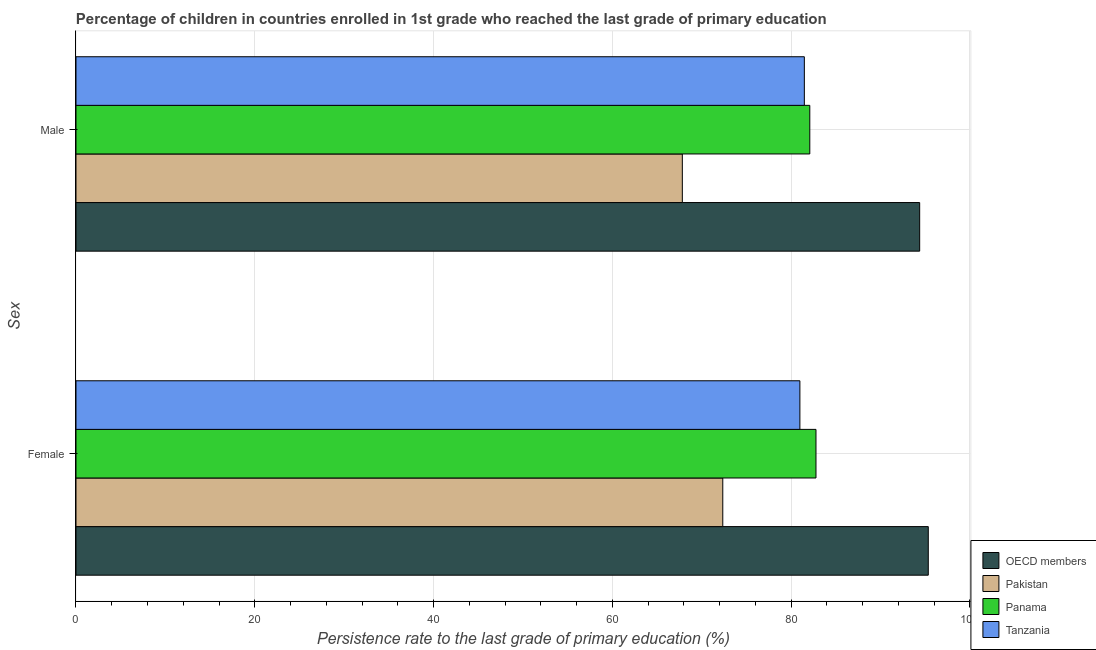How many different coloured bars are there?
Provide a short and direct response. 4. Are the number of bars per tick equal to the number of legend labels?
Ensure brevity in your answer.  Yes. How many bars are there on the 2nd tick from the bottom?
Your answer should be very brief. 4. What is the persistence rate of female students in OECD members?
Offer a very short reply. 95.36. Across all countries, what is the maximum persistence rate of male students?
Offer a terse response. 94.39. Across all countries, what is the minimum persistence rate of male students?
Your answer should be very brief. 67.84. In which country was the persistence rate of male students minimum?
Provide a succinct answer. Pakistan. What is the total persistence rate of male students in the graph?
Give a very brief answer. 325.82. What is the difference between the persistence rate of female students in Tanzania and that in Pakistan?
Your answer should be very brief. 8.63. What is the difference between the persistence rate of female students in OECD members and the persistence rate of male students in Panama?
Your answer should be very brief. 13.26. What is the average persistence rate of male students per country?
Make the answer very short. 81.46. What is the difference between the persistence rate of female students and persistence rate of male students in OECD members?
Your response must be concise. 0.96. In how many countries, is the persistence rate of female students greater than 28 %?
Give a very brief answer. 4. What is the ratio of the persistence rate of male students in Tanzania to that in OECD members?
Offer a terse response. 0.86. Is the persistence rate of female students in Pakistan less than that in Panama?
Make the answer very short. Yes. What does the 2nd bar from the top in Female represents?
Provide a succinct answer. Panama. What is the difference between two consecutive major ticks on the X-axis?
Your response must be concise. 20. Does the graph contain grids?
Offer a terse response. Yes. Where does the legend appear in the graph?
Your answer should be very brief. Bottom right. What is the title of the graph?
Your answer should be compact. Percentage of children in countries enrolled in 1st grade who reached the last grade of primary education. Does "Cuba" appear as one of the legend labels in the graph?
Offer a very short reply. No. What is the label or title of the X-axis?
Your answer should be very brief. Persistence rate to the last grade of primary education (%). What is the label or title of the Y-axis?
Your answer should be compact. Sex. What is the Persistence rate to the last grade of primary education (%) in OECD members in Female?
Offer a very short reply. 95.36. What is the Persistence rate to the last grade of primary education (%) in Pakistan in Female?
Provide a succinct answer. 72.36. What is the Persistence rate to the last grade of primary education (%) of Panama in Female?
Keep it short and to the point. 82.79. What is the Persistence rate to the last grade of primary education (%) of Tanzania in Female?
Offer a very short reply. 80.99. What is the Persistence rate to the last grade of primary education (%) of OECD members in Male?
Your answer should be compact. 94.39. What is the Persistence rate to the last grade of primary education (%) in Pakistan in Male?
Provide a succinct answer. 67.84. What is the Persistence rate to the last grade of primary education (%) in Panama in Male?
Offer a terse response. 82.1. What is the Persistence rate to the last grade of primary education (%) of Tanzania in Male?
Ensure brevity in your answer.  81.49. Across all Sex, what is the maximum Persistence rate to the last grade of primary education (%) of OECD members?
Your answer should be compact. 95.36. Across all Sex, what is the maximum Persistence rate to the last grade of primary education (%) of Pakistan?
Your answer should be very brief. 72.36. Across all Sex, what is the maximum Persistence rate to the last grade of primary education (%) of Panama?
Give a very brief answer. 82.79. Across all Sex, what is the maximum Persistence rate to the last grade of primary education (%) in Tanzania?
Make the answer very short. 81.49. Across all Sex, what is the minimum Persistence rate to the last grade of primary education (%) in OECD members?
Your answer should be very brief. 94.39. Across all Sex, what is the minimum Persistence rate to the last grade of primary education (%) in Pakistan?
Keep it short and to the point. 67.84. Across all Sex, what is the minimum Persistence rate to the last grade of primary education (%) in Panama?
Offer a very short reply. 82.1. Across all Sex, what is the minimum Persistence rate to the last grade of primary education (%) of Tanzania?
Offer a very short reply. 80.99. What is the total Persistence rate to the last grade of primary education (%) in OECD members in the graph?
Keep it short and to the point. 189.75. What is the total Persistence rate to the last grade of primary education (%) in Pakistan in the graph?
Provide a short and direct response. 140.2. What is the total Persistence rate to the last grade of primary education (%) in Panama in the graph?
Provide a succinct answer. 164.89. What is the total Persistence rate to the last grade of primary education (%) in Tanzania in the graph?
Keep it short and to the point. 162.48. What is the difference between the Persistence rate to the last grade of primary education (%) in OECD members in Female and that in Male?
Provide a short and direct response. 0.96. What is the difference between the Persistence rate to the last grade of primary education (%) of Pakistan in Female and that in Male?
Your response must be concise. 4.52. What is the difference between the Persistence rate to the last grade of primary education (%) in Panama in Female and that in Male?
Offer a very short reply. 0.69. What is the difference between the Persistence rate to the last grade of primary education (%) in Tanzania in Female and that in Male?
Ensure brevity in your answer.  -0.5. What is the difference between the Persistence rate to the last grade of primary education (%) in OECD members in Female and the Persistence rate to the last grade of primary education (%) in Pakistan in Male?
Keep it short and to the point. 27.52. What is the difference between the Persistence rate to the last grade of primary education (%) in OECD members in Female and the Persistence rate to the last grade of primary education (%) in Panama in Male?
Your answer should be compact. 13.26. What is the difference between the Persistence rate to the last grade of primary education (%) in OECD members in Female and the Persistence rate to the last grade of primary education (%) in Tanzania in Male?
Provide a succinct answer. 13.87. What is the difference between the Persistence rate to the last grade of primary education (%) in Pakistan in Female and the Persistence rate to the last grade of primary education (%) in Panama in Male?
Your answer should be compact. -9.74. What is the difference between the Persistence rate to the last grade of primary education (%) of Pakistan in Female and the Persistence rate to the last grade of primary education (%) of Tanzania in Male?
Make the answer very short. -9.13. What is the difference between the Persistence rate to the last grade of primary education (%) in Panama in Female and the Persistence rate to the last grade of primary education (%) in Tanzania in Male?
Ensure brevity in your answer.  1.3. What is the average Persistence rate to the last grade of primary education (%) of OECD members per Sex?
Offer a terse response. 94.87. What is the average Persistence rate to the last grade of primary education (%) of Pakistan per Sex?
Give a very brief answer. 70.1. What is the average Persistence rate to the last grade of primary education (%) of Panama per Sex?
Offer a terse response. 82.45. What is the average Persistence rate to the last grade of primary education (%) of Tanzania per Sex?
Offer a very short reply. 81.24. What is the difference between the Persistence rate to the last grade of primary education (%) of OECD members and Persistence rate to the last grade of primary education (%) of Pakistan in Female?
Keep it short and to the point. 22.99. What is the difference between the Persistence rate to the last grade of primary education (%) in OECD members and Persistence rate to the last grade of primary education (%) in Panama in Female?
Give a very brief answer. 12.56. What is the difference between the Persistence rate to the last grade of primary education (%) of OECD members and Persistence rate to the last grade of primary education (%) of Tanzania in Female?
Your answer should be very brief. 14.36. What is the difference between the Persistence rate to the last grade of primary education (%) of Pakistan and Persistence rate to the last grade of primary education (%) of Panama in Female?
Provide a short and direct response. -10.43. What is the difference between the Persistence rate to the last grade of primary education (%) in Pakistan and Persistence rate to the last grade of primary education (%) in Tanzania in Female?
Provide a short and direct response. -8.63. What is the difference between the Persistence rate to the last grade of primary education (%) of Panama and Persistence rate to the last grade of primary education (%) of Tanzania in Female?
Keep it short and to the point. 1.8. What is the difference between the Persistence rate to the last grade of primary education (%) of OECD members and Persistence rate to the last grade of primary education (%) of Pakistan in Male?
Make the answer very short. 26.55. What is the difference between the Persistence rate to the last grade of primary education (%) in OECD members and Persistence rate to the last grade of primary education (%) in Panama in Male?
Your response must be concise. 12.29. What is the difference between the Persistence rate to the last grade of primary education (%) of OECD members and Persistence rate to the last grade of primary education (%) of Tanzania in Male?
Offer a very short reply. 12.9. What is the difference between the Persistence rate to the last grade of primary education (%) in Pakistan and Persistence rate to the last grade of primary education (%) in Panama in Male?
Offer a very short reply. -14.26. What is the difference between the Persistence rate to the last grade of primary education (%) of Pakistan and Persistence rate to the last grade of primary education (%) of Tanzania in Male?
Keep it short and to the point. -13.65. What is the difference between the Persistence rate to the last grade of primary education (%) of Panama and Persistence rate to the last grade of primary education (%) of Tanzania in Male?
Provide a short and direct response. 0.61. What is the ratio of the Persistence rate to the last grade of primary education (%) in OECD members in Female to that in Male?
Make the answer very short. 1.01. What is the ratio of the Persistence rate to the last grade of primary education (%) of Pakistan in Female to that in Male?
Provide a succinct answer. 1.07. What is the ratio of the Persistence rate to the last grade of primary education (%) in Panama in Female to that in Male?
Keep it short and to the point. 1.01. What is the ratio of the Persistence rate to the last grade of primary education (%) in Tanzania in Female to that in Male?
Keep it short and to the point. 0.99. What is the difference between the highest and the second highest Persistence rate to the last grade of primary education (%) in OECD members?
Your answer should be very brief. 0.96. What is the difference between the highest and the second highest Persistence rate to the last grade of primary education (%) of Pakistan?
Offer a terse response. 4.52. What is the difference between the highest and the second highest Persistence rate to the last grade of primary education (%) of Panama?
Ensure brevity in your answer.  0.69. What is the difference between the highest and the second highest Persistence rate to the last grade of primary education (%) in Tanzania?
Your answer should be very brief. 0.5. What is the difference between the highest and the lowest Persistence rate to the last grade of primary education (%) of OECD members?
Ensure brevity in your answer.  0.96. What is the difference between the highest and the lowest Persistence rate to the last grade of primary education (%) in Pakistan?
Ensure brevity in your answer.  4.52. What is the difference between the highest and the lowest Persistence rate to the last grade of primary education (%) of Panama?
Make the answer very short. 0.69. What is the difference between the highest and the lowest Persistence rate to the last grade of primary education (%) in Tanzania?
Make the answer very short. 0.5. 